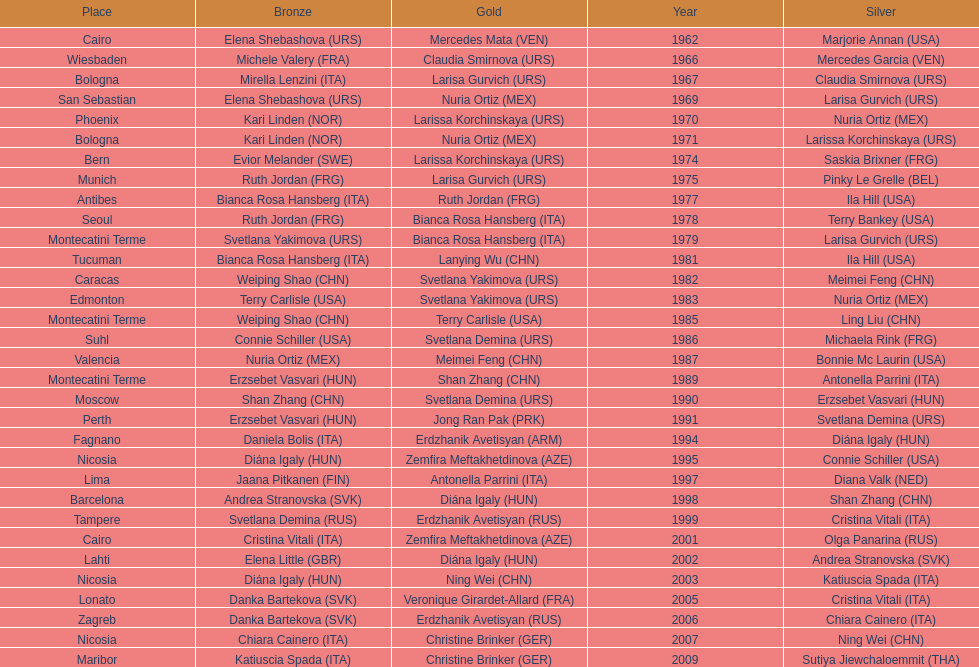Who won the only gold medal in 1962? Mercedes Mata. 